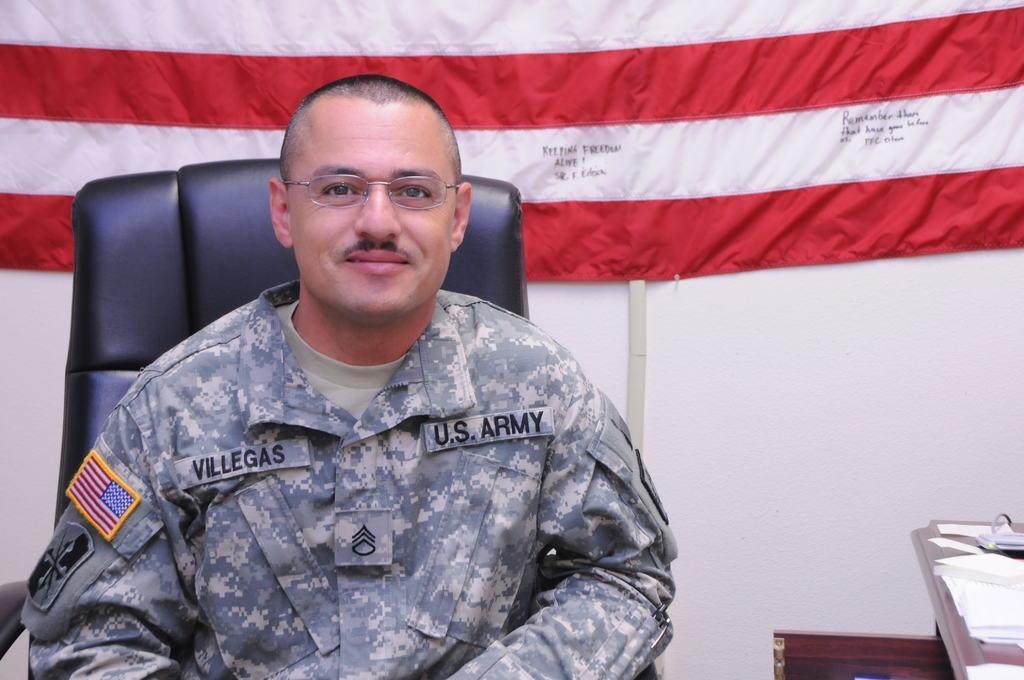In one or two sentences, can you explain what this image depicts? In the image I can see a person who is sitting on the chair and beside there is a table on which there are some papers and behind there is a flag. 